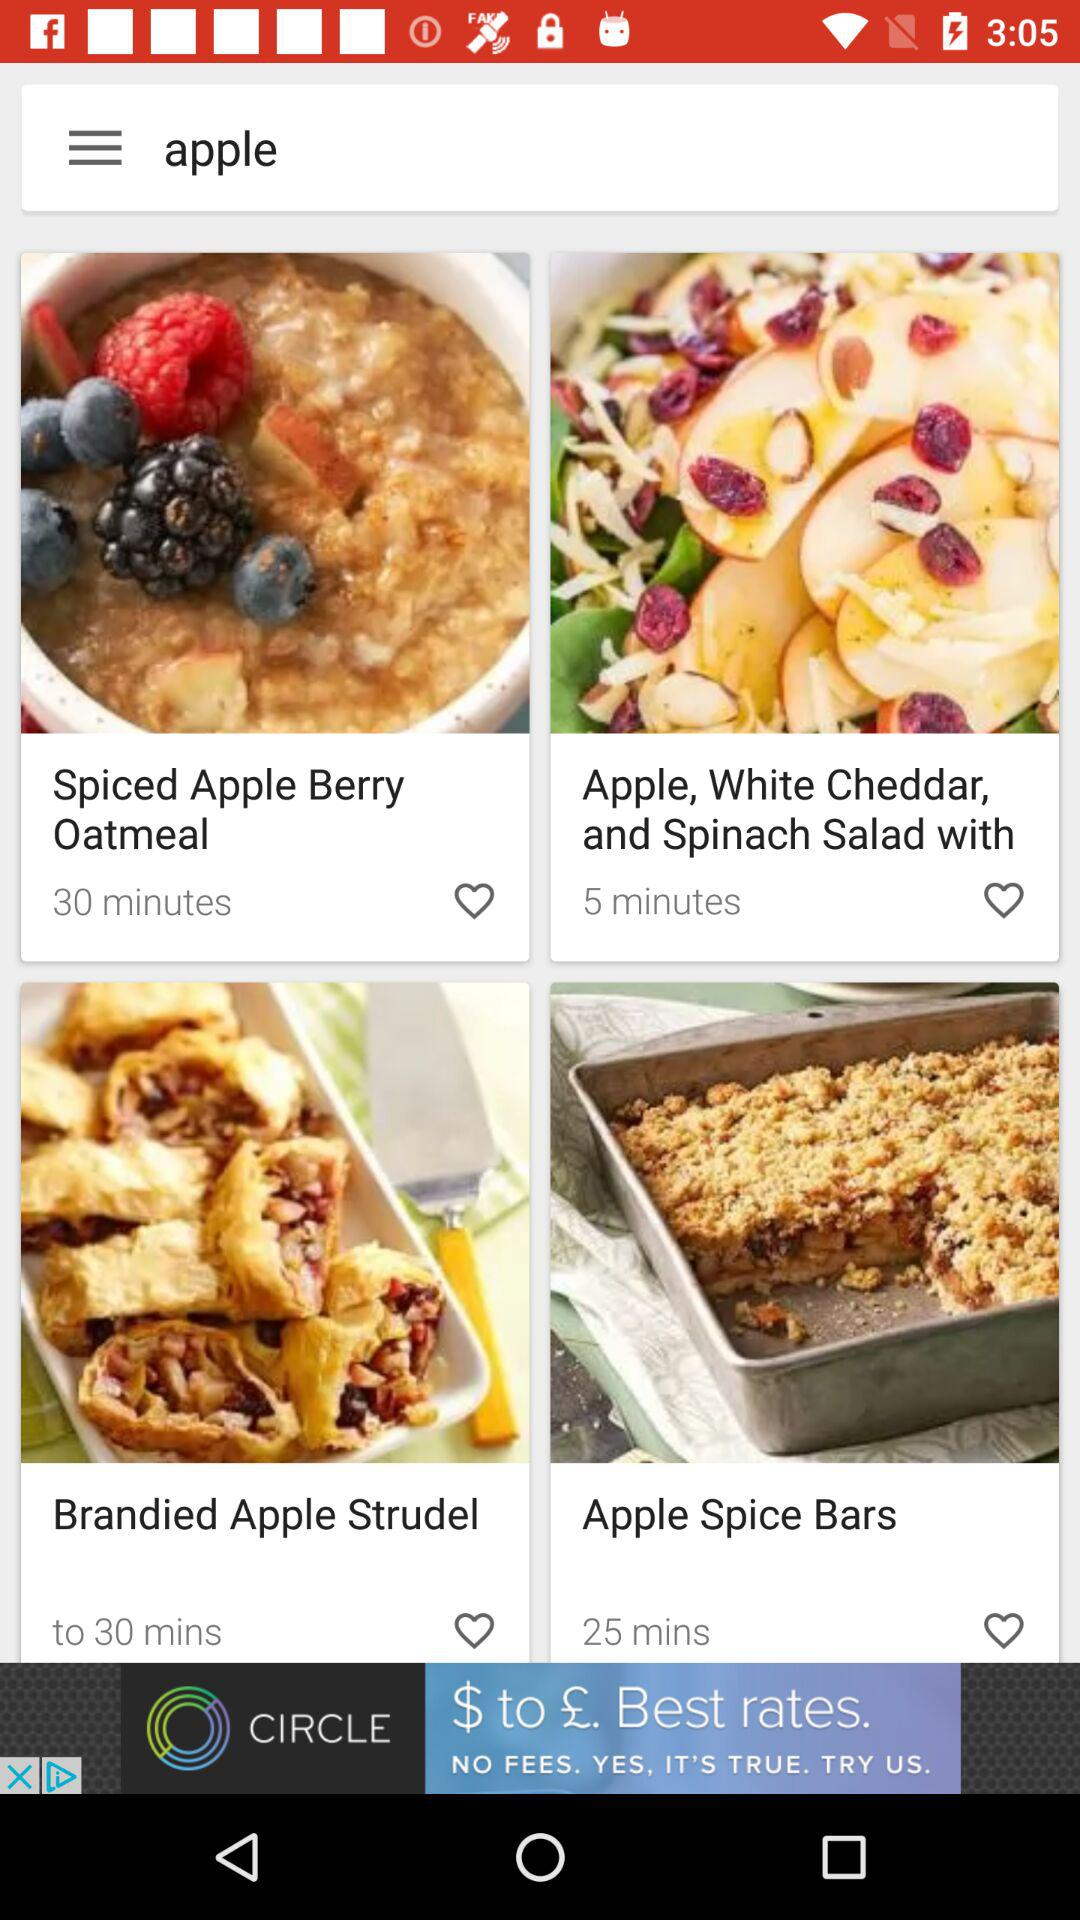For what dish is 25 minutes allotted? The dish is "Apple Spice Bars". 